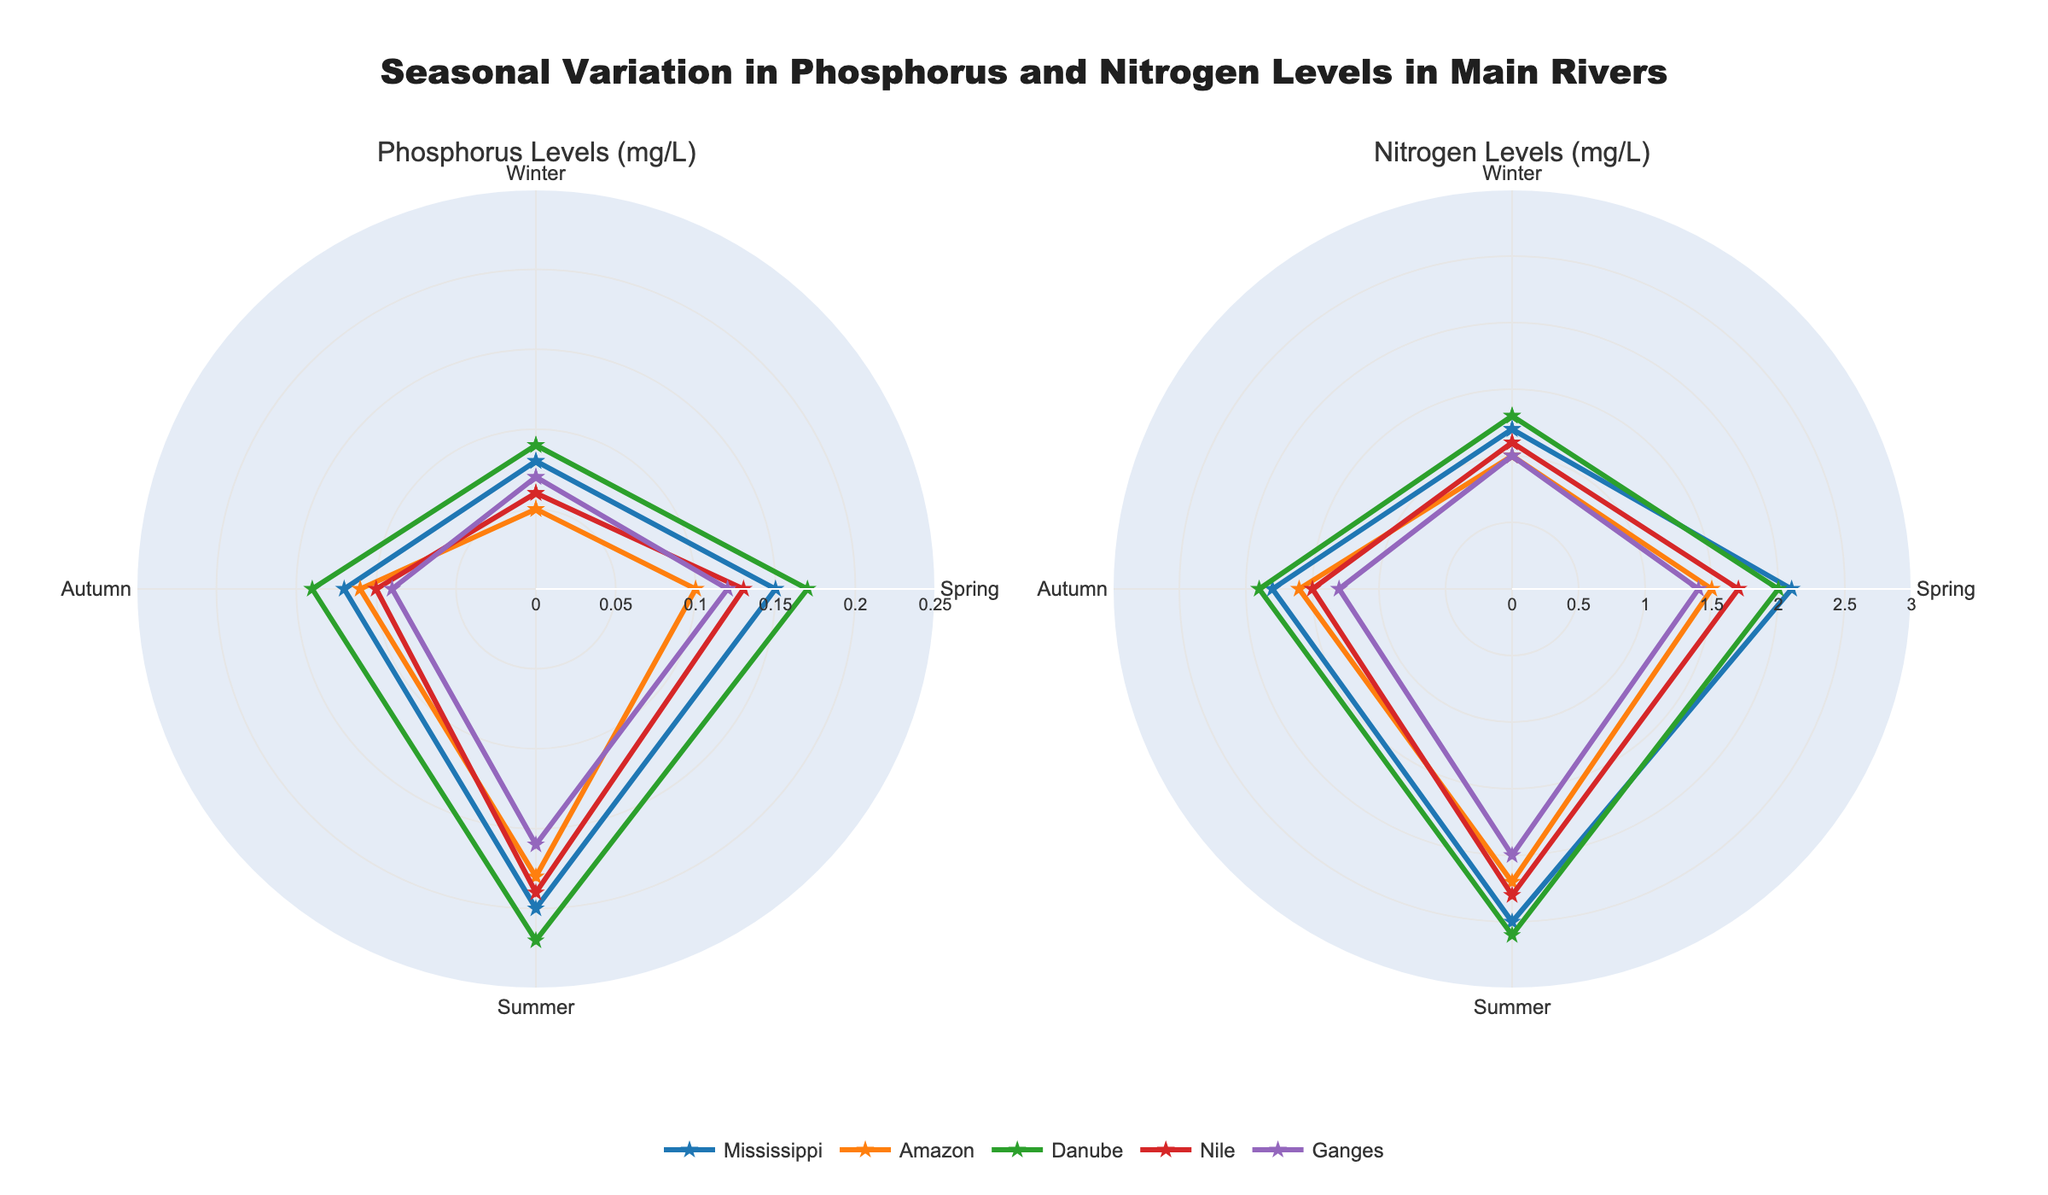what is the title of the figure? The title is usually placed at the top center of the figure and it provides a brief description of what the figure is showing. In this case, it would be "Seasonal Variation in Phosphorus and Nitrogen Levels in Main Rivers".
Answer: "Seasonal Variation in Phosphorus and Nitrogen Levels in Main Rivers" Which river has the highest phosphorus level in winter? By looking at the first radar chart (Phosphorus Levels), find the point corresponding to 'Winter' for all rivers. The river with the largest radial value at this point will have the highest phosphorus level.
Answer: Danube Which river shows the largest seasonal variability in nitrogen levels? Analyze the second radar chart (Nitrogen Levels) for the overall shape and spread of values for each river. The river with the most spread-out or uneven line across seasons indicates the highest variability.
Answer: Nile or Danube (detailed check necessary for precise answer) How does the nitrogen level in the Nile compare between Winter and Summer? On the second radar chart (Nitrogen Levels), note the radial values of the Nile in 'Winter' compared to 'Summer'. Subtract the Winter value from the Summer value to determine the increase.
Answer: It increases by 1.2 mg/L What is the average phosphorus level in the Amazon across all seasons? On the first radar chart, note the radial values of the Amazon for all seasons then sum them up and divide by the number of seasons (4) to find the average.
Answer: (0.05 + 0.10 + 0.18 + 0.11) / 4 = 0.11 mg/L Which river has the least variation in phosphorus levels throughout the year? On the first radar chart, look for the river with the most consistent or least spread-out line across all seasons. The least variable river will have the most stable/even line.
Answer: Amazon During which season does the Mississippi River have the highest nitrogen level? In the second radar chart (Nitrogen Levels), find the radial values for the Mississippi River and identify the season with the peak value.
Answer: Summer Which river has the lowest average nitrogen levels across all seasons? For each river in the second radar chart, calculate the average radial value of nitrogen over all seasons. The river with the smallest average will be the answer.
Answer: Ganges (average: (1.0 + 1.4 + 2.0 + 1.3)/4 = 1.425 mg/L) How many distinct seasons are represented in each radar chart? By examining the radar charts, count the different labeled points along the angular axis which represent seasons. Every radar chart in this plot contains these labels.
Answer: 4 